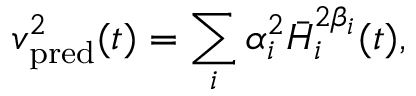Convert formula to latex. <formula><loc_0><loc_0><loc_500><loc_500>v _ { p r e d } ^ { 2 } ( t ) = \sum _ { i } \alpha _ { i } ^ { 2 } \bar { H } _ { i } ^ { 2 \beta _ { i } } ( t ) ,</formula> 